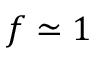Convert formula to latex. <formula><loc_0><loc_0><loc_500><loc_500>f \simeq 1</formula> 